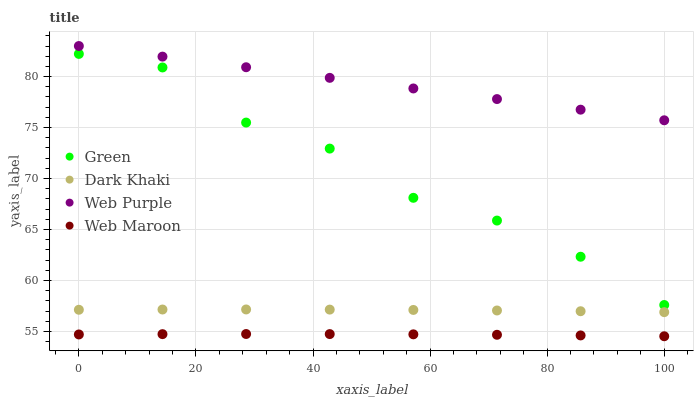Does Web Maroon have the minimum area under the curve?
Answer yes or no. Yes. Does Web Purple have the maximum area under the curve?
Answer yes or no. Yes. Does Web Purple have the minimum area under the curve?
Answer yes or no. No. Does Web Maroon have the maximum area under the curve?
Answer yes or no. No. Is Web Purple the smoothest?
Answer yes or no. Yes. Is Green the roughest?
Answer yes or no. Yes. Is Web Maroon the smoothest?
Answer yes or no. No. Is Web Maroon the roughest?
Answer yes or no. No. Does Web Maroon have the lowest value?
Answer yes or no. Yes. Does Web Purple have the lowest value?
Answer yes or no. No. Does Web Purple have the highest value?
Answer yes or no. Yes. Does Web Maroon have the highest value?
Answer yes or no. No. Is Web Maroon less than Dark Khaki?
Answer yes or no. Yes. Is Web Purple greater than Web Maroon?
Answer yes or no. Yes. Does Web Maroon intersect Dark Khaki?
Answer yes or no. No. 